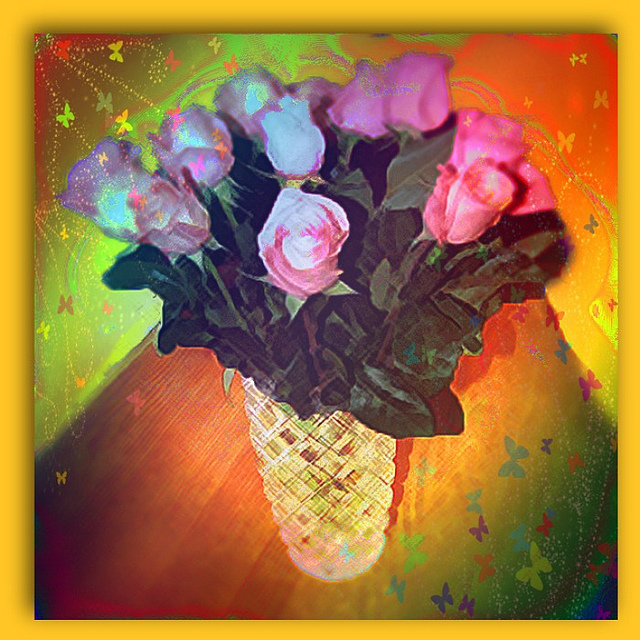Could you describe the artistic style used in this image? The image appears to employ a digital art style with a somewhat impressionistic quality, using vibrant colors and visible brushstrokes to create an abstract interpretation of a bouquet of flowers. The background has been altered with a gradient of warm colors, speckled with playful elements like stars and butterflies, which adds a whimsical and dreamy atmosphere. 